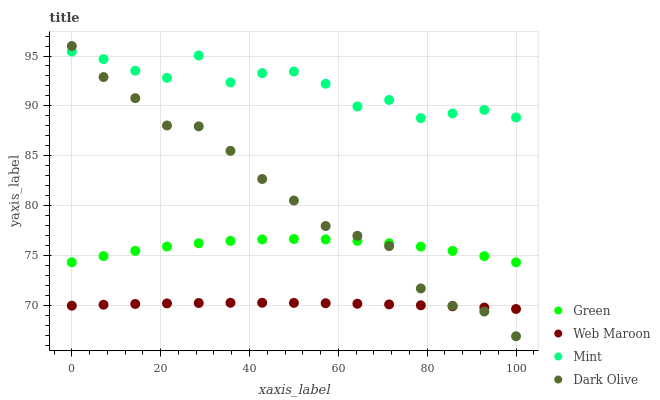Does Web Maroon have the minimum area under the curve?
Answer yes or no. Yes. Does Mint have the maximum area under the curve?
Answer yes or no. Yes. Does Dark Olive have the minimum area under the curve?
Answer yes or no. No. Does Dark Olive have the maximum area under the curve?
Answer yes or no. No. Is Web Maroon the smoothest?
Answer yes or no. Yes. Is Mint the roughest?
Answer yes or no. Yes. Is Dark Olive the smoothest?
Answer yes or no. No. Is Dark Olive the roughest?
Answer yes or no. No. Does Dark Olive have the lowest value?
Answer yes or no. Yes. Does Green have the lowest value?
Answer yes or no. No. Does Dark Olive have the highest value?
Answer yes or no. Yes. Does Green have the highest value?
Answer yes or no. No. Is Green less than Mint?
Answer yes or no. Yes. Is Green greater than Web Maroon?
Answer yes or no. Yes. Does Web Maroon intersect Dark Olive?
Answer yes or no. Yes. Is Web Maroon less than Dark Olive?
Answer yes or no. No. Is Web Maroon greater than Dark Olive?
Answer yes or no. No. Does Green intersect Mint?
Answer yes or no. No. 